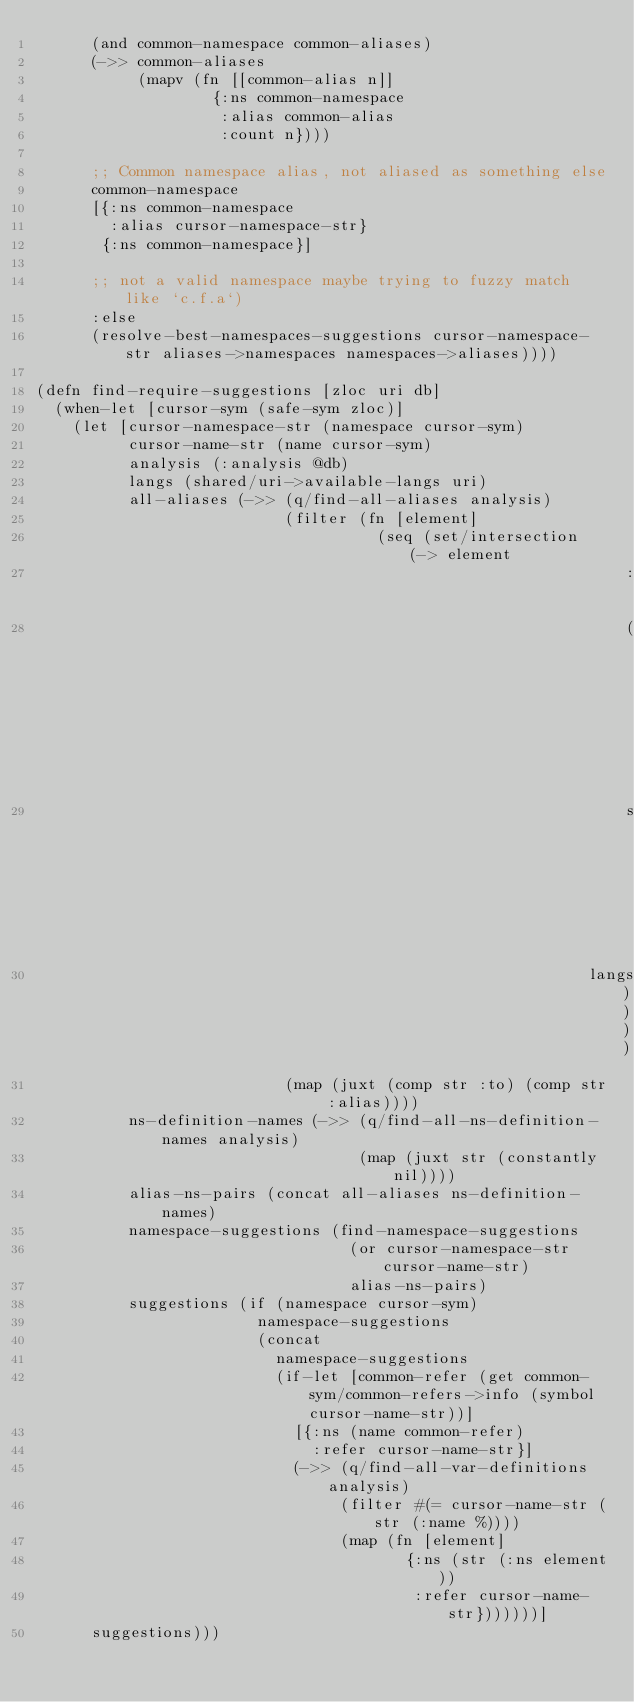Convert code to text. <code><loc_0><loc_0><loc_500><loc_500><_Clojure_>      (and common-namespace common-aliases)
      (->> common-aliases
           (mapv (fn [[common-alias n]]
                   {:ns common-namespace
                    :alias common-alias
                    :count n})))

      ;; Common namespace alias, not aliased as something else
      common-namespace
      [{:ns common-namespace
        :alias cursor-namespace-str}
       {:ns common-namespace}]

      ;; not a valid namespace maybe trying to fuzzy match like `c.f.a`)
      :else
      (resolve-best-namespaces-suggestions cursor-namespace-str aliases->namespaces namespaces->aliases))))

(defn find-require-suggestions [zloc uri db]
  (when-let [cursor-sym (safe-sym zloc)]
    (let [cursor-namespace-str (namespace cursor-sym)
          cursor-name-str (name cursor-sym)
          analysis (:analysis @db)
          langs (shared/uri->available-langs uri)
          all-aliases (->> (q/find-all-aliases analysis)
                           (filter (fn [element]
                                     (seq (set/intersection (-> element
                                                                :filename
                                                                (shared/filename->uri db)
                                                                shared/uri->available-langs)
                                                            langs))))
                           (map (juxt (comp str :to) (comp str :alias))))
          ns-definition-names (->> (q/find-all-ns-definition-names analysis)
                                   (map (juxt str (constantly nil))))
          alias-ns-pairs (concat all-aliases ns-definition-names)
          namespace-suggestions (find-namespace-suggestions
                                  (or cursor-namespace-str cursor-name-str)
                                  alias-ns-pairs)
          suggestions (if (namespace cursor-sym)
                        namespace-suggestions
                        (concat
                          namespace-suggestions
                          (if-let [common-refer (get common-sym/common-refers->info (symbol cursor-name-str))]
                            [{:ns (name common-refer)
                              :refer cursor-name-str}]
                            (->> (q/find-all-var-definitions analysis)
                                 (filter #(= cursor-name-str (str (:name %))))
                                 (map (fn [element]
                                        {:ns (str (:ns element))
                                         :refer cursor-name-str}))))))]
      suggestions)))
</code> 